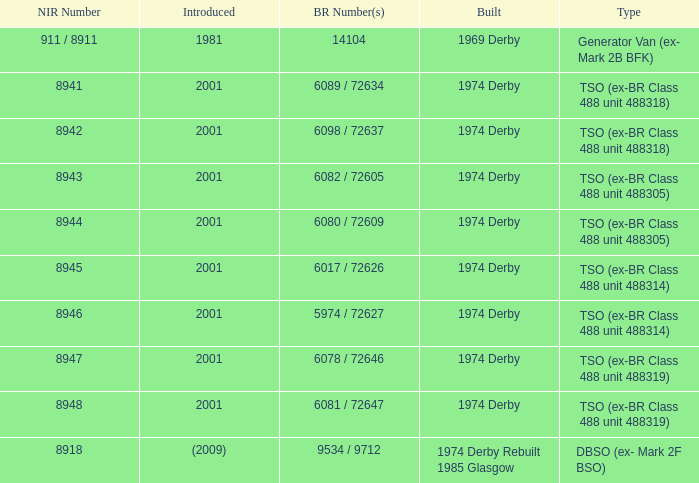For the tso type (previously br class 488 unit 488305) with a 6082 / 72605 br number, what is the corresponding nir number? 8943.0. 